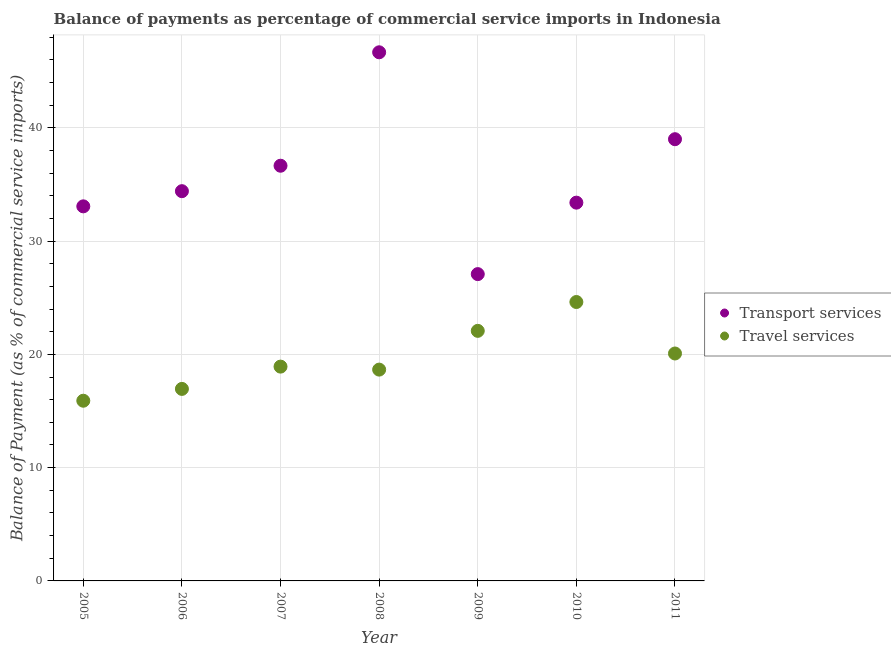Is the number of dotlines equal to the number of legend labels?
Provide a succinct answer. Yes. What is the balance of payments of transport services in 2008?
Offer a terse response. 46.67. Across all years, what is the maximum balance of payments of transport services?
Give a very brief answer. 46.67. Across all years, what is the minimum balance of payments of travel services?
Provide a short and direct response. 15.91. In which year was the balance of payments of travel services minimum?
Your response must be concise. 2005. What is the total balance of payments of travel services in the graph?
Your answer should be compact. 137.21. What is the difference between the balance of payments of transport services in 2005 and that in 2008?
Provide a short and direct response. -13.6. What is the difference between the balance of payments of travel services in 2007 and the balance of payments of transport services in 2006?
Provide a succinct answer. -15.49. What is the average balance of payments of transport services per year?
Provide a short and direct response. 35.75. In the year 2008, what is the difference between the balance of payments of travel services and balance of payments of transport services?
Give a very brief answer. -28.01. What is the ratio of the balance of payments of travel services in 2005 to that in 2006?
Make the answer very short. 0.94. Is the balance of payments of transport services in 2006 less than that in 2008?
Offer a very short reply. Yes. What is the difference between the highest and the second highest balance of payments of transport services?
Give a very brief answer. 7.67. What is the difference between the highest and the lowest balance of payments of transport services?
Offer a very short reply. 19.58. In how many years, is the balance of payments of transport services greater than the average balance of payments of transport services taken over all years?
Your response must be concise. 3. Is the sum of the balance of payments of travel services in 2005 and 2008 greater than the maximum balance of payments of transport services across all years?
Give a very brief answer. No. Does the balance of payments of travel services monotonically increase over the years?
Make the answer very short. No. How many dotlines are there?
Make the answer very short. 2. What is the difference between two consecutive major ticks on the Y-axis?
Your answer should be very brief. 10. Are the values on the major ticks of Y-axis written in scientific E-notation?
Offer a terse response. No. Does the graph contain any zero values?
Make the answer very short. No. Does the graph contain grids?
Provide a succinct answer. Yes. How are the legend labels stacked?
Make the answer very short. Vertical. What is the title of the graph?
Your response must be concise. Balance of payments as percentage of commercial service imports in Indonesia. Does "Merchandise exports" appear as one of the legend labels in the graph?
Your answer should be very brief. No. What is the label or title of the X-axis?
Your response must be concise. Year. What is the label or title of the Y-axis?
Offer a very short reply. Balance of Payment (as % of commercial service imports). What is the Balance of Payment (as % of commercial service imports) in Transport services in 2005?
Offer a terse response. 33.07. What is the Balance of Payment (as % of commercial service imports) in Travel services in 2005?
Provide a short and direct response. 15.91. What is the Balance of Payment (as % of commercial service imports) of Transport services in 2006?
Offer a very short reply. 34.41. What is the Balance of Payment (as % of commercial service imports) in Travel services in 2006?
Provide a short and direct response. 16.95. What is the Balance of Payment (as % of commercial service imports) of Transport services in 2007?
Your response must be concise. 36.65. What is the Balance of Payment (as % of commercial service imports) in Travel services in 2007?
Give a very brief answer. 18.92. What is the Balance of Payment (as % of commercial service imports) of Transport services in 2008?
Ensure brevity in your answer.  46.67. What is the Balance of Payment (as % of commercial service imports) of Travel services in 2008?
Make the answer very short. 18.65. What is the Balance of Payment (as % of commercial service imports) of Transport services in 2009?
Offer a terse response. 27.08. What is the Balance of Payment (as % of commercial service imports) in Travel services in 2009?
Keep it short and to the point. 22.08. What is the Balance of Payment (as % of commercial service imports) in Transport services in 2010?
Offer a terse response. 33.39. What is the Balance of Payment (as % of commercial service imports) in Travel services in 2010?
Your answer should be very brief. 24.62. What is the Balance of Payment (as % of commercial service imports) in Transport services in 2011?
Keep it short and to the point. 38.99. What is the Balance of Payment (as % of commercial service imports) in Travel services in 2011?
Offer a very short reply. 20.08. Across all years, what is the maximum Balance of Payment (as % of commercial service imports) of Transport services?
Your response must be concise. 46.67. Across all years, what is the maximum Balance of Payment (as % of commercial service imports) of Travel services?
Offer a very short reply. 24.62. Across all years, what is the minimum Balance of Payment (as % of commercial service imports) in Transport services?
Keep it short and to the point. 27.08. Across all years, what is the minimum Balance of Payment (as % of commercial service imports) in Travel services?
Offer a very short reply. 15.91. What is the total Balance of Payment (as % of commercial service imports) in Transport services in the graph?
Keep it short and to the point. 250.27. What is the total Balance of Payment (as % of commercial service imports) of Travel services in the graph?
Offer a terse response. 137.21. What is the difference between the Balance of Payment (as % of commercial service imports) in Transport services in 2005 and that in 2006?
Your answer should be compact. -1.34. What is the difference between the Balance of Payment (as % of commercial service imports) in Travel services in 2005 and that in 2006?
Provide a succinct answer. -1.04. What is the difference between the Balance of Payment (as % of commercial service imports) of Transport services in 2005 and that in 2007?
Give a very brief answer. -3.59. What is the difference between the Balance of Payment (as % of commercial service imports) of Travel services in 2005 and that in 2007?
Give a very brief answer. -3.01. What is the difference between the Balance of Payment (as % of commercial service imports) in Transport services in 2005 and that in 2008?
Offer a very short reply. -13.6. What is the difference between the Balance of Payment (as % of commercial service imports) of Travel services in 2005 and that in 2008?
Ensure brevity in your answer.  -2.75. What is the difference between the Balance of Payment (as % of commercial service imports) in Transport services in 2005 and that in 2009?
Provide a succinct answer. 5.98. What is the difference between the Balance of Payment (as % of commercial service imports) in Travel services in 2005 and that in 2009?
Offer a terse response. -6.17. What is the difference between the Balance of Payment (as % of commercial service imports) in Transport services in 2005 and that in 2010?
Your response must be concise. -0.33. What is the difference between the Balance of Payment (as % of commercial service imports) in Travel services in 2005 and that in 2010?
Make the answer very short. -8.71. What is the difference between the Balance of Payment (as % of commercial service imports) of Transport services in 2005 and that in 2011?
Give a very brief answer. -5.93. What is the difference between the Balance of Payment (as % of commercial service imports) in Travel services in 2005 and that in 2011?
Your answer should be compact. -4.17. What is the difference between the Balance of Payment (as % of commercial service imports) of Transport services in 2006 and that in 2007?
Offer a terse response. -2.25. What is the difference between the Balance of Payment (as % of commercial service imports) in Travel services in 2006 and that in 2007?
Keep it short and to the point. -1.97. What is the difference between the Balance of Payment (as % of commercial service imports) of Transport services in 2006 and that in 2008?
Give a very brief answer. -12.26. What is the difference between the Balance of Payment (as % of commercial service imports) of Travel services in 2006 and that in 2008?
Offer a terse response. -1.7. What is the difference between the Balance of Payment (as % of commercial service imports) of Transport services in 2006 and that in 2009?
Offer a very short reply. 7.32. What is the difference between the Balance of Payment (as % of commercial service imports) in Travel services in 2006 and that in 2009?
Give a very brief answer. -5.12. What is the difference between the Balance of Payment (as % of commercial service imports) of Transport services in 2006 and that in 2010?
Provide a short and direct response. 1.01. What is the difference between the Balance of Payment (as % of commercial service imports) of Travel services in 2006 and that in 2010?
Keep it short and to the point. -7.67. What is the difference between the Balance of Payment (as % of commercial service imports) in Transport services in 2006 and that in 2011?
Offer a very short reply. -4.59. What is the difference between the Balance of Payment (as % of commercial service imports) in Travel services in 2006 and that in 2011?
Provide a short and direct response. -3.13. What is the difference between the Balance of Payment (as % of commercial service imports) of Transport services in 2007 and that in 2008?
Make the answer very short. -10.01. What is the difference between the Balance of Payment (as % of commercial service imports) of Travel services in 2007 and that in 2008?
Make the answer very short. 0.26. What is the difference between the Balance of Payment (as % of commercial service imports) in Transport services in 2007 and that in 2009?
Offer a terse response. 9.57. What is the difference between the Balance of Payment (as % of commercial service imports) of Travel services in 2007 and that in 2009?
Provide a short and direct response. -3.16. What is the difference between the Balance of Payment (as % of commercial service imports) of Transport services in 2007 and that in 2010?
Your answer should be very brief. 3.26. What is the difference between the Balance of Payment (as % of commercial service imports) of Travel services in 2007 and that in 2010?
Make the answer very short. -5.7. What is the difference between the Balance of Payment (as % of commercial service imports) of Transport services in 2007 and that in 2011?
Offer a very short reply. -2.34. What is the difference between the Balance of Payment (as % of commercial service imports) in Travel services in 2007 and that in 2011?
Your answer should be very brief. -1.16. What is the difference between the Balance of Payment (as % of commercial service imports) in Transport services in 2008 and that in 2009?
Your answer should be very brief. 19.58. What is the difference between the Balance of Payment (as % of commercial service imports) of Travel services in 2008 and that in 2009?
Offer a very short reply. -3.42. What is the difference between the Balance of Payment (as % of commercial service imports) of Transport services in 2008 and that in 2010?
Offer a terse response. 13.27. What is the difference between the Balance of Payment (as % of commercial service imports) in Travel services in 2008 and that in 2010?
Your answer should be very brief. -5.97. What is the difference between the Balance of Payment (as % of commercial service imports) of Transport services in 2008 and that in 2011?
Your answer should be compact. 7.67. What is the difference between the Balance of Payment (as % of commercial service imports) of Travel services in 2008 and that in 2011?
Offer a very short reply. -1.42. What is the difference between the Balance of Payment (as % of commercial service imports) of Transport services in 2009 and that in 2010?
Your answer should be very brief. -6.31. What is the difference between the Balance of Payment (as % of commercial service imports) of Travel services in 2009 and that in 2010?
Give a very brief answer. -2.55. What is the difference between the Balance of Payment (as % of commercial service imports) of Transport services in 2009 and that in 2011?
Your answer should be compact. -11.91. What is the difference between the Balance of Payment (as % of commercial service imports) in Travel services in 2009 and that in 2011?
Keep it short and to the point. 2. What is the difference between the Balance of Payment (as % of commercial service imports) in Transport services in 2010 and that in 2011?
Offer a terse response. -5.6. What is the difference between the Balance of Payment (as % of commercial service imports) of Travel services in 2010 and that in 2011?
Offer a terse response. 4.54. What is the difference between the Balance of Payment (as % of commercial service imports) in Transport services in 2005 and the Balance of Payment (as % of commercial service imports) in Travel services in 2006?
Offer a very short reply. 16.12. What is the difference between the Balance of Payment (as % of commercial service imports) of Transport services in 2005 and the Balance of Payment (as % of commercial service imports) of Travel services in 2007?
Offer a very short reply. 14.15. What is the difference between the Balance of Payment (as % of commercial service imports) of Transport services in 2005 and the Balance of Payment (as % of commercial service imports) of Travel services in 2008?
Your answer should be very brief. 14.41. What is the difference between the Balance of Payment (as % of commercial service imports) of Transport services in 2005 and the Balance of Payment (as % of commercial service imports) of Travel services in 2009?
Your answer should be very brief. 10.99. What is the difference between the Balance of Payment (as % of commercial service imports) in Transport services in 2005 and the Balance of Payment (as % of commercial service imports) in Travel services in 2010?
Make the answer very short. 8.45. What is the difference between the Balance of Payment (as % of commercial service imports) in Transport services in 2005 and the Balance of Payment (as % of commercial service imports) in Travel services in 2011?
Offer a terse response. 12.99. What is the difference between the Balance of Payment (as % of commercial service imports) in Transport services in 2006 and the Balance of Payment (as % of commercial service imports) in Travel services in 2007?
Your answer should be very brief. 15.49. What is the difference between the Balance of Payment (as % of commercial service imports) of Transport services in 2006 and the Balance of Payment (as % of commercial service imports) of Travel services in 2008?
Your response must be concise. 15.75. What is the difference between the Balance of Payment (as % of commercial service imports) of Transport services in 2006 and the Balance of Payment (as % of commercial service imports) of Travel services in 2009?
Ensure brevity in your answer.  12.33. What is the difference between the Balance of Payment (as % of commercial service imports) in Transport services in 2006 and the Balance of Payment (as % of commercial service imports) in Travel services in 2010?
Your answer should be very brief. 9.78. What is the difference between the Balance of Payment (as % of commercial service imports) in Transport services in 2006 and the Balance of Payment (as % of commercial service imports) in Travel services in 2011?
Keep it short and to the point. 14.33. What is the difference between the Balance of Payment (as % of commercial service imports) in Transport services in 2007 and the Balance of Payment (as % of commercial service imports) in Travel services in 2008?
Your answer should be very brief. 18. What is the difference between the Balance of Payment (as % of commercial service imports) in Transport services in 2007 and the Balance of Payment (as % of commercial service imports) in Travel services in 2009?
Give a very brief answer. 14.58. What is the difference between the Balance of Payment (as % of commercial service imports) in Transport services in 2007 and the Balance of Payment (as % of commercial service imports) in Travel services in 2010?
Keep it short and to the point. 12.03. What is the difference between the Balance of Payment (as % of commercial service imports) in Transport services in 2007 and the Balance of Payment (as % of commercial service imports) in Travel services in 2011?
Your answer should be compact. 16.58. What is the difference between the Balance of Payment (as % of commercial service imports) of Transport services in 2008 and the Balance of Payment (as % of commercial service imports) of Travel services in 2009?
Ensure brevity in your answer.  24.59. What is the difference between the Balance of Payment (as % of commercial service imports) in Transport services in 2008 and the Balance of Payment (as % of commercial service imports) in Travel services in 2010?
Your answer should be very brief. 22.04. What is the difference between the Balance of Payment (as % of commercial service imports) of Transport services in 2008 and the Balance of Payment (as % of commercial service imports) of Travel services in 2011?
Your answer should be compact. 26.59. What is the difference between the Balance of Payment (as % of commercial service imports) of Transport services in 2009 and the Balance of Payment (as % of commercial service imports) of Travel services in 2010?
Provide a succinct answer. 2.46. What is the difference between the Balance of Payment (as % of commercial service imports) of Transport services in 2009 and the Balance of Payment (as % of commercial service imports) of Travel services in 2011?
Keep it short and to the point. 7.01. What is the difference between the Balance of Payment (as % of commercial service imports) of Transport services in 2010 and the Balance of Payment (as % of commercial service imports) of Travel services in 2011?
Your answer should be compact. 13.32. What is the average Balance of Payment (as % of commercial service imports) of Transport services per year?
Provide a short and direct response. 35.75. What is the average Balance of Payment (as % of commercial service imports) in Travel services per year?
Offer a terse response. 19.6. In the year 2005, what is the difference between the Balance of Payment (as % of commercial service imports) of Transport services and Balance of Payment (as % of commercial service imports) of Travel services?
Your answer should be very brief. 17.16. In the year 2006, what is the difference between the Balance of Payment (as % of commercial service imports) of Transport services and Balance of Payment (as % of commercial service imports) of Travel services?
Your response must be concise. 17.46. In the year 2007, what is the difference between the Balance of Payment (as % of commercial service imports) in Transport services and Balance of Payment (as % of commercial service imports) in Travel services?
Your answer should be very brief. 17.73. In the year 2008, what is the difference between the Balance of Payment (as % of commercial service imports) in Transport services and Balance of Payment (as % of commercial service imports) in Travel services?
Provide a succinct answer. 28.01. In the year 2009, what is the difference between the Balance of Payment (as % of commercial service imports) in Transport services and Balance of Payment (as % of commercial service imports) in Travel services?
Make the answer very short. 5.01. In the year 2010, what is the difference between the Balance of Payment (as % of commercial service imports) of Transport services and Balance of Payment (as % of commercial service imports) of Travel services?
Provide a short and direct response. 8.77. In the year 2011, what is the difference between the Balance of Payment (as % of commercial service imports) of Transport services and Balance of Payment (as % of commercial service imports) of Travel services?
Provide a short and direct response. 18.92. What is the ratio of the Balance of Payment (as % of commercial service imports) in Transport services in 2005 to that in 2006?
Your answer should be compact. 0.96. What is the ratio of the Balance of Payment (as % of commercial service imports) of Travel services in 2005 to that in 2006?
Give a very brief answer. 0.94. What is the ratio of the Balance of Payment (as % of commercial service imports) in Transport services in 2005 to that in 2007?
Give a very brief answer. 0.9. What is the ratio of the Balance of Payment (as % of commercial service imports) of Travel services in 2005 to that in 2007?
Your answer should be very brief. 0.84. What is the ratio of the Balance of Payment (as % of commercial service imports) of Transport services in 2005 to that in 2008?
Your answer should be compact. 0.71. What is the ratio of the Balance of Payment (as % of commercial service imports) of Travel services in 2005 to that in 2008?
Make the answer very short. 0.85. What is the ratio of the Balance of Payment (as % of commercial service imports) of Transport services in 2005 to that in 2009?
Your answer should be compact. 1.22. What is the ratio of the Balance of Payment (as % of commercial service imports) of Travel services in 2005 to that in 2009?
Your answer should be compact. 0.72. What is the ratio of the Balance of Payment (as % of commercial service imports) of Transport services in 2005 to that in 2010?
Your answer should be very brief. 0.99. What is the ratio of the Balance of Payment (as % of commercial service imports) in Travel services in 2005 to that in 2010?
Keep it short and to the point. 0.65. What is the ratio of the Balance of Payment (as % of commercial service imports) of Transport services in 2005 to that in 2011?
Offer a terse response. 0.85. What is the ratio of the Balance of Payment (as % of commercial service imports) of Travel services in 2005 to that in 2011?
Provide a succinct answer. 0.79. What is the ratio of the Balance of Payment (as % of commercial service imports) of Transport services in 2006 to that in 2007?
Your answer should be very brief. 0.94. What is the ratio of the Balance of Payment (as % of commercial service imports) of Travel services in 2006 to that in 2007?
Provide a succinct answer. 0.9. What is the ratio of the Balance of Payment (as % of commercial service imports) in Transport services in 2006 to that in 2008?
Provide a short and direct response. 0.74. What is the ratio of the Balance of Payment (as % of commercial service imports) of Travel services in 2006 to that in 2008?
Your answer should be compact. 0.91. What is the ratio of the Balance of Payment (as % of commercial service imports) of Transport services in 2006 to that in 2009?
Your response must be concise. 1.27. What is the ratio of the Balance of Payment (as % of commercial service imports) of Travel services in 2006 to that in 2009?
Offer a very short reply. 0.77. What is the ratio of the Balance of Payment (as % of commercial service imports) in Transport services in 2006 to that in 2010?
Keep it short and to the point. 1.03. What is the ratio of the Balance of Payment (as % of commercial service imports) in Travel services in 2006 to that in 2010?
Keep it short and to the point. 0.69. What is the ratio of the Balance of Payment (as % of commercial service imports) of Transport services in 2006 to that in 2011?
Keep it short and to the point. 0.88. What is the ratio of the Balance of Payment (as % of commercial service imports) of Travel services in 2006 to that in 2011?
Your answer should be compact. 0.84. What is the ratio of the Balance of Payment (as % of commercial service imports) of Transport services in 2007 to that in 2008?
Make the answer very short. 0.79. What is the ratio of the Balance of Payment (as % of commercial service imports) in Travel services in 2007 to that in 2008?
Provide a succinct answer. 1.01. What is the ratio of the Balance of Payment (as % of commercial service imports) in Transport services in 2007 to that in 2009?
Your answer should be compact. 1.35. What is the ratio of the Balance of Payment (as % of commercial service imports) of Travel services in 2007 to that in 2009?
Give a very brief answer. 0.86. What is the ratio of the Balance of Payment (as % of commercial service imports) of Transport services in 2007 to that in 2010?
Your answer should be very brief. 1.1. What is the ratio of the Balance of Payment (as % of commercial service imports) in Travel services in 2007 to that in 2010?
Offer a very short reply. 0.77. What is the ratio of the Balance of Payment (as % of commercial service imports) of Transport services in 2007 to that in 2011?
Make the answer very short. 0.94. What is the ratio of the Balance of Payment (as % of commercial service imports) of Travel services in 2007 to that in 2011?
Give a very brief answer. 0.94. What is the ratio of the Balance of Payment (as % of commercial service imports) of Transport services in 2008 to that in 2009?
Keep it short and to the point. 1.72. What is the ratio of the Balance of Payment (as % of commercial service imports) in Travel services in 2008 to that in 2009?
Your answer should be compact. 0.84. What is the ratio of the Balance of Payment (as % of commercial service imports) of Transport services in 2008 to that in 2010?
Make the answer very short. 1.4. What is the ratio of the Balance of Payment (as % of commercial service imports) of Travel services in 2008 to that in 2010?
Make the answer very short. 0.76. What is the ratio of the Balance of Payment (as % of commercial service imports) of Transport services in 2008 to that in 2011?
Provide a succinct answer. 1.2. What is the ratio of the Balance of Payment (as % of commercial service imports) of Travel services in 2008 to that in 2011?
Make the answer very short. 0.93. What is the ratio of the Balance of Payment (as % of commercial service imports) of Transport services in 2009 to that in 2010?
Ensure brevity in your answer.  0.81. What is the ratio of the Balance of Payment (as % of commercial service imports) in Travel services in 2009 to that in 2010?
Keep it short and to the point. 0.9. What is the ratio of the Balance of Payment (as % of commercial service imports) in Transport services in 2009 to that in 2011?
Your answer should be compact. 0.69. What is the ratio of the Balance of Payment (as % of commercial service imports) in Travel services in 2009 to that in 2011?
Offer a very short reply. 1.1. What is the ratio of the Balance of Payment (as % of commercial service imports) of Transport services in 2010 to that in 2011?
Give a very brief answer. 0.86. What is the ratio of the Balance of Payment (as % of commercial service imports) of Travel services in 2010 to that in 2011?
Ensure brevity in your answer.  1.23. What is the difference between the highest and the second highest Balance of Payment (as % of commercial service imports) of Transport services?
Ensure brevity in your answer.  7.67. What is the difference between the highest and the second highest Balance of Payment (as % of commercial service imports) of Travel services?
Give a very brief answer. 2.55. What is the difference between the highest and the lowest Balance of Payment (as % of commercial service imports) in Transport services?
Your answer should be very brief. 19.58. What is the difference between the highest and the lowest Balance of Payment (as % of commercial service imports) in Travel services?
Provide a succinct answer. 8.71. 